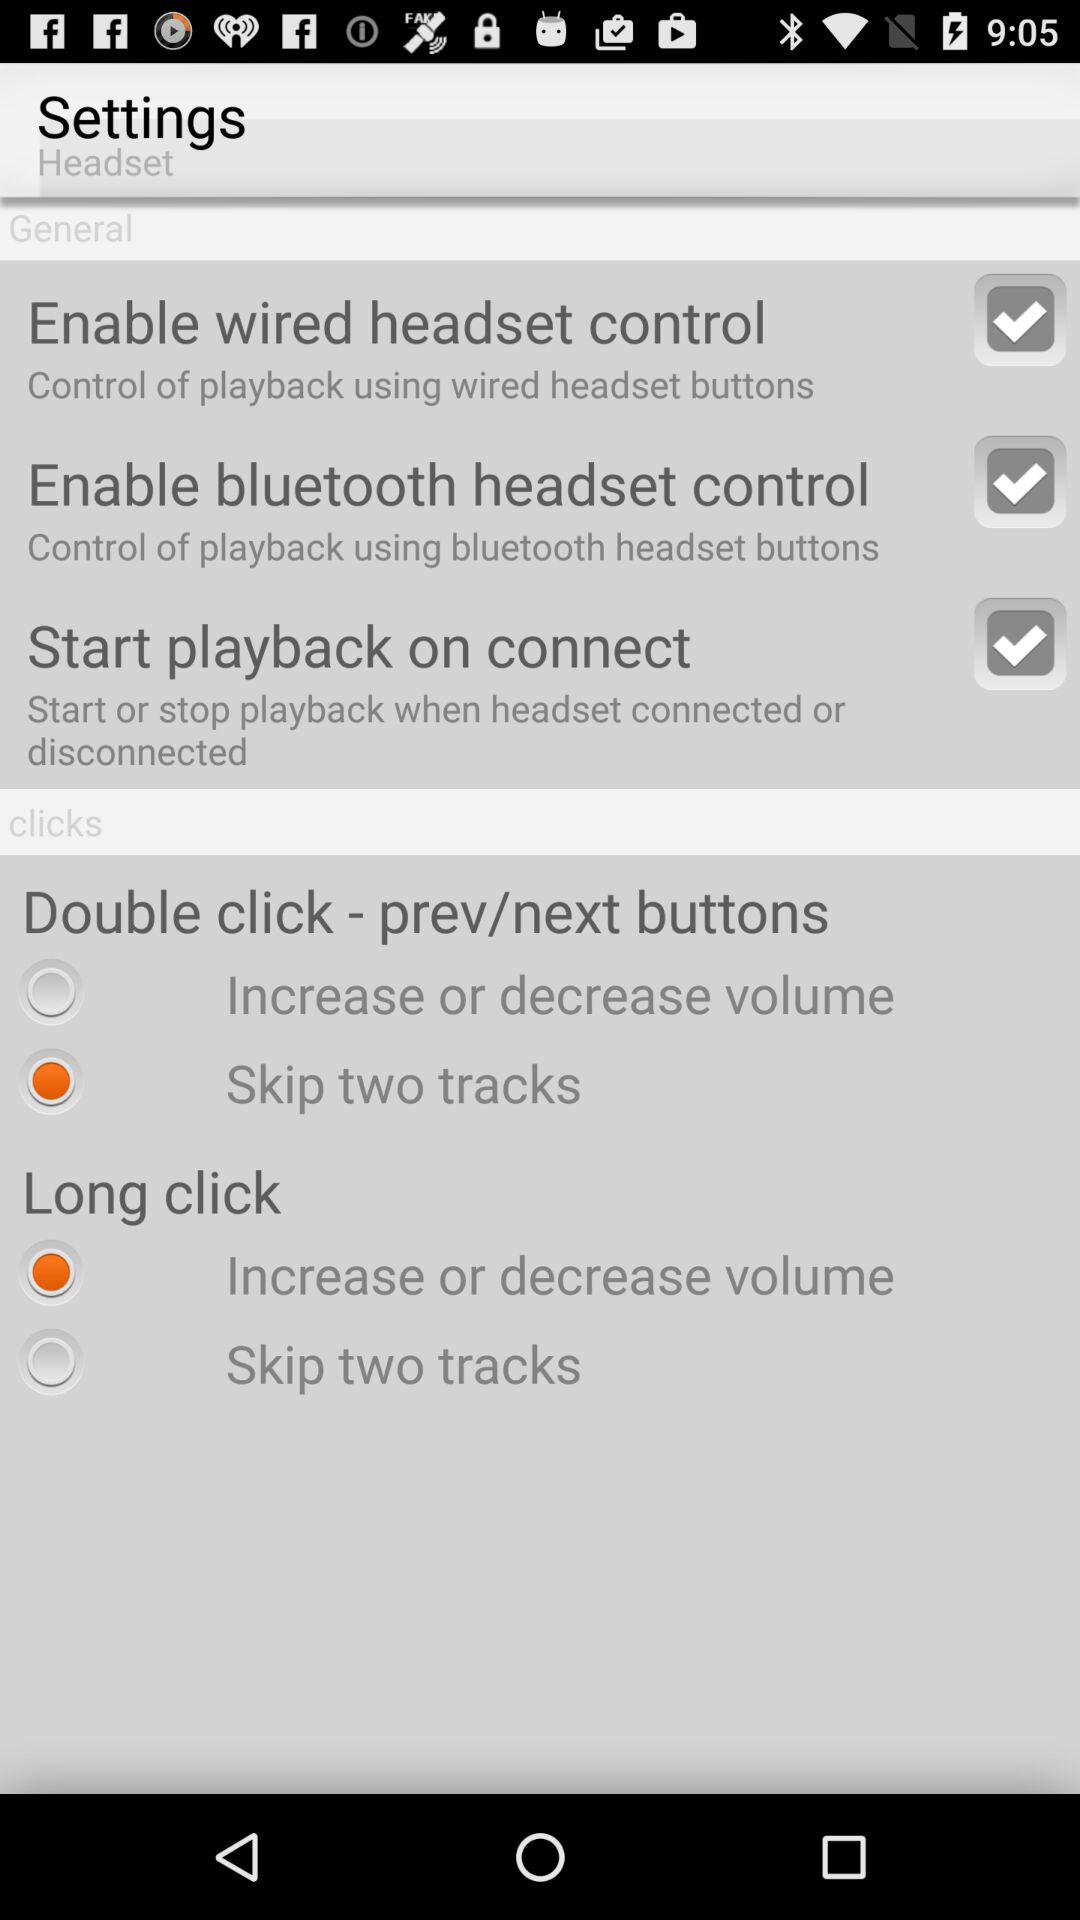Which general setting options are selected? The selected general options are "Enable wired headset control", "Enable bluetooth headset control" and "Start playback on connect". 